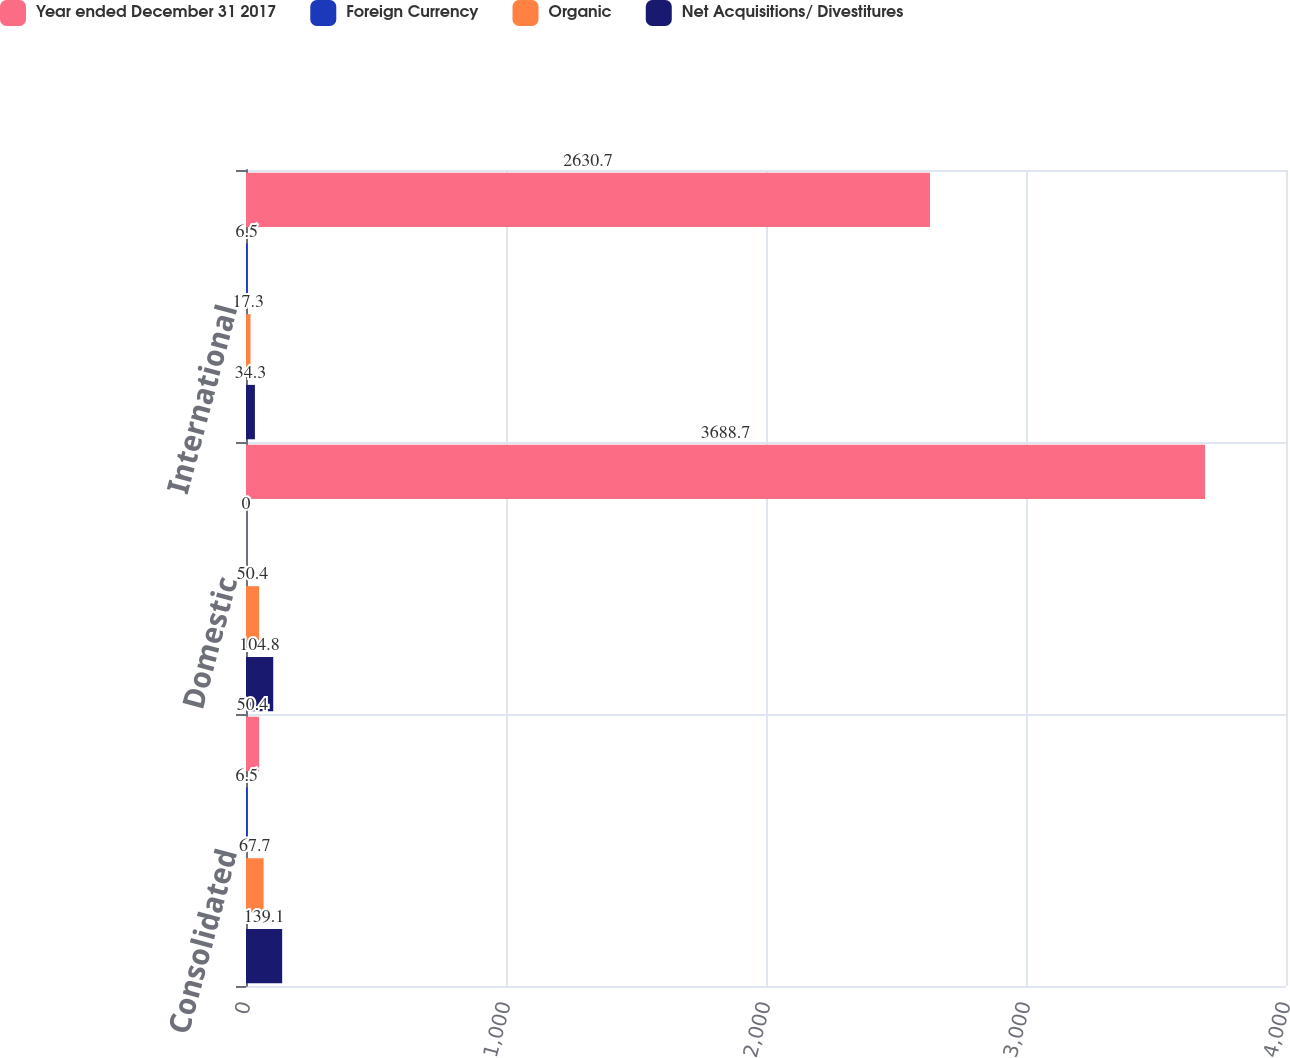Convert chart to OTSL. <chart><loc_0><loc_0><loc_500><loc_500><stacked_bar_chart><ecel><fcel>Consolidated<fcel>Domestic<fcel>International<nl><fcel>Year ended December 31 2017<fcel>50.4<fcel>3688.7<fcel>2630.7<nl><fcel>Foreign Currency<fcel>6.5<fcel>0<fcel>6.5<nl><fcel>Organic<fcel>67.7<fcel>50.4<fcel>17.3<nl><fcel>Net Acquisitions/ Divestitures<fcel>139.1<fcel>104.8<fcel>34.3<nl></chart> 